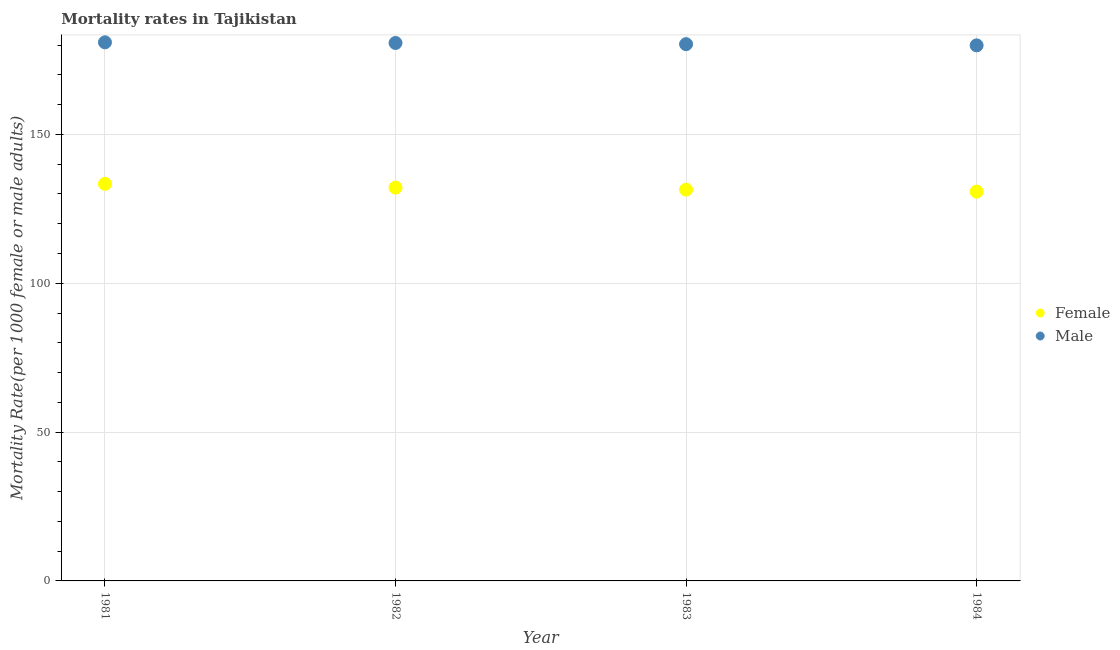What is the female mortality rate in 1981?
Offer a terse response. 133.38. Across all years, what is the maximum female mortality rate?
Your answer should be compact. 133.38. Across all years, what is the minimum female mortality rate?
Give a very brief answer. 130.76. In which year was the female mortality rate minimum?
Provide a succinct answer. 1984. What is the total female mortality rate in the graph?
Keep it short and to the point. 527.71. What is the difference between the male mortality rate in 1982 and that in 1984?
Your answer should be compact. 0.8. What is the difference between the female mortality rate in 1981 and the male mortality rate in 1983?
Give a very brief answer. -46.93. What is the average male mortality rate per year?
Make the answer very short. 180.47. In the year 1983, what is the difference between the male mortality rate and female mortality rate?
Your response must be concise. 48.87. In how many years, is the male mortality rate greater than 170?
Ensure brevity in your answer.  4. What is the ratio of the male mortality rate in 1982 to that in 1983?
Give a very brief answer. 1. Is the male mortality rate in 1982 less than that in 1983?
Give a very brief answer. No. Is the difference between the female mortality rate in 1983 and 1984 greater than the difference between the male mortality rate in 1983 and 1984?
Your answer should be very brief. Yes. What is the difference between the highest and the second highest female mortality rate?
Offer a very short reply. 1.26. What is the difference between the highest and the lowest female mortality rate?
Offer a very short reply. 2.62. In how many years, is the male mortality rate greater than the average male mortality rate taken over all years?
Keep it short and to the point. 2. Is the sum of the male mortality rate in 1981 and 1982 greater than the maximum female mortality rate across all years?
Your response must be concise. Yes. Is the male mortality rate strictly less than the female mortality rate over the years?
Provide a succinct answer. No. How many years are there in the graph?
Provide a short and direct response. 4. What is the difference between two consecutive major ticks on the Y-axis?
Keep it short and to the point. 50. Are the values on the major ticks of Y-axis written in scientific E-notation?
Offer a very short reply. No. How many legend labels are there?
Give a very brief answer. 2. What is the title of the graph?
Provide a succinct answer. Mortality rates in Tajikistan. What is the label or title of the Y-axis?
Your answer should be very brief. Mortality Rate(per 1000 female or male adults). What is the Mortality Rate(per 1000 female or male adults) of Female in 1981?
Keep it short and to the point. 133.38. What is the Mortality Rate(per 1000 female or male adults) of Male in 1981?
Make the answer very short. 180.93. What is the Mortality Rate(per 1000 female or male adults) of Female in 1982?
Keep it short and to the point. 132.12. What is the Mortality Rate(per 1000 female or male adults) in Male in 1982?
Offer a terse response. 180.71. What is the Mortality Rate(per 1000 female or male adults) of Female in 1983?
Provide a succinct answer. 131.44. What is the Mortality Rate(per 1000 female or male adults) in Male in 1983?
Your answer should be very brief. 180.31. What is the Mortality Rate(per 1000 female or male adults) in Female in 1984?
Provide a short and direct response. 130.76. What is the Mortality Rate(per 1000 female or male adults) of Male in 1984?
Provide a short and direct response. 179.91. Across all years, what is the maximum Mortality Rate(per 1000 female or male adults) of Female?
Your answer should be very brief. 133.38. Across all years, what is the maximum Mortality Rate(per 1000 female or male adults) in Male?
Your answer should be very brief. 180.93. Across all years, what is the minimum Mortality Rate(per 1000 female or male adults) in Female?
Give a very brief answer. 130.76. Across all years, what is the minimum Mortality Rate(per 1000 female or male adults) of Male?
Provide a succinct answer. 179.91. What is the total Mortality Rate(per 1000 female or male adults) in Female in the graph?
Provide a succinct answer. 527.71. What is the total Mortality Rate(per 1000 female or male adults) of Male in the graph?
Your answer should be compact. 721.86. What is the difference between the Mortality Rate(per 1000 female or male adults) of Female in 1981 and that in 1982?
Ensure brevity in your answer.  1.26. What is the difference between the Mortality Rate(per 1000 female or male adults) in Male in 1981 and that in 1982?
Provide a succinct answer. 0.22. What is the difference between the Mortality Rate(per 1000 female or male adults) of Female in 1981 and that in 1983?
Provide a succinct answer. 1.94. What is the difference between the Mortality Rate(per 1000 female or male adults) in Male in 1981 and that in 1983?
Give a very brief answer. 0.62. What is the difference between the Mortality Rate(per 1000 female or male adults) in Female in 1981 and that in 1984?
Your response must be concise. 2.62. What is the difference between the Mortality Rate(per 1000 female or male adults) in Male in 1981 and that in 1984?
Give a very brief answer. 1.02. What is the difference between the Mortality Rate(per 1000 female or male adults) of Female in 1982 and that in 1983?
Ensure brevity in your answer.  0.68. What is the difference between the Mortality Rate(per 1000 female or male adults) in Male in 1982 and that in 1983?
Offer a very short reply. 0.4. What is the difference between the Mortality Rate(per 1000 female or male adults) of Female in 1982 and that in 1984?
Your answer should be compact. 1.36. What is the difference between the Mortality Rate(per 1000 female or male adults) of Female in 1983 and that in 1984?
Give a very brief answer. 0.68. What is the difference between the Mortality Rate(per 1000 female or male adults) in Female in 1981 and the Mortality Rate(per 1000 female or male adults) in Male in 1982?
Provide a succinct answer. -47.33. What is the difference between the Mortality Rate(per 1000 female or male adults) of Female in 1981 and the Mortality Rate(per 1000 female or male adults) of Male in 1983?
Keep it short and to the point. -46.93. What is the difference between the Mortality Rate(per 1000 female or male adults) of Female in 1981 and the Mortality Rate(per 1000 female or male adults) of Male in 1984?
Give a very brief answer. -46.53. What is the difference between the Mortality Rate(per 1000 female or male adults) in Female in 1982 and the Mortality Rate(per 1000 female or male adults) in Male in 1983?
Ensure brevity in your answer.  -48.19. What is the difference between the Mortality Rate(per 1000 female or male adults) of Female in 1982 and the Mortality Rate(per 1000 female or male adults) of Male in 1984?
Provide a short and direct response. -47.79. What is the difference between the Mortality Rate(per 1000 female or male adults) of Female in 1983 and the Mortality Rate(per 1000 female or male adults) of Male in 1984?
Your response must be concise. -48.47. What is the average Mortality Rate(per 1000 female or male adults) of Female per year?
Your answer should be compact. 131.93. What is the average Mortality Rate(per 1000 female or male adults) of Male per year?
Your answer should be very brief. 180.47. In the year 1981, what is the difference between the Mortality Rate(per 1000 female or male adults) in Female and Mortality Rate(per 1000 female or male adults) in Male?
Your answer should be very brief. -47.55. In the year 1982, what is the difference between the Mortality Rate(per 1000 female or male adults) of Female and Mortality Rate(per 1000 female or male adults) of Male?
Make the answer very short. -48.59. In the year 1983, what is the difference between the Mortality Rate(per 1000 female or male adults) of Female and Mortality Rate(per 1000 female or male adults) of Male?
Provide a succinct answer. -48.87. In the year 1984, what is the difference between the Mortality Rate(per 1000 female or male adults) of Female and Mortality Rate(per 1000 female or male adults) of Male?
Give a very brief answer. -49.15. What is the ratio of the Mortality Rate(per 1000 female or male adults) of Female in 1981 to that in 1982?
Offer a very short reply. 1.01. What is the ratio of the Mortality Rate(per 1000 female or male adults) in Female in 1981 to that in 1983?
Provide a short and direct response. 1.01. What is the ratio of the Mortality Rate(per 1000 female or male adults) in Male in 1981 to that in 1983?
Your response must be concise. 1. What is the ratio of the Mortality Rate(per 1000 female or male adults) of Male in 1981 to that in 1984?
Offer a very short reply. 1.01. What is the ratio of the Mortality Rate(per 1000 female or male adults) of Female in 1982 to that in 1984?
Provide a succinct answer. 1.01. What is the ratio of the Mortality Rate(per 1000 female or male adults) in Male in 1982 to that in 1984?
Keep it short and to the point. 1. What is the ratio of the Mortality Rate(per 1000 female or male adults) of Male in 1983 to that in 1984?
Make the answer very short. 1. What is the difference between the highest and the second highest Mortality Rate(per 1000 female or male adults) of Female?
Your response must be concise. 1.26. What is the difference between the highest and the second highest Mortality Rate(per 1000 female or male adults) of Male?
Provide a succinct answer. 0.22. What is the difference between the highest and the lowest Mortality Rate(per 1000 female or male adults) of Female?
Offer a very short reply. 2.62. What is the difference between the highest and the lowest Mortality Rate(per 1000 female or male adults) of Male?
Provide a short and direct response. 1.02. 